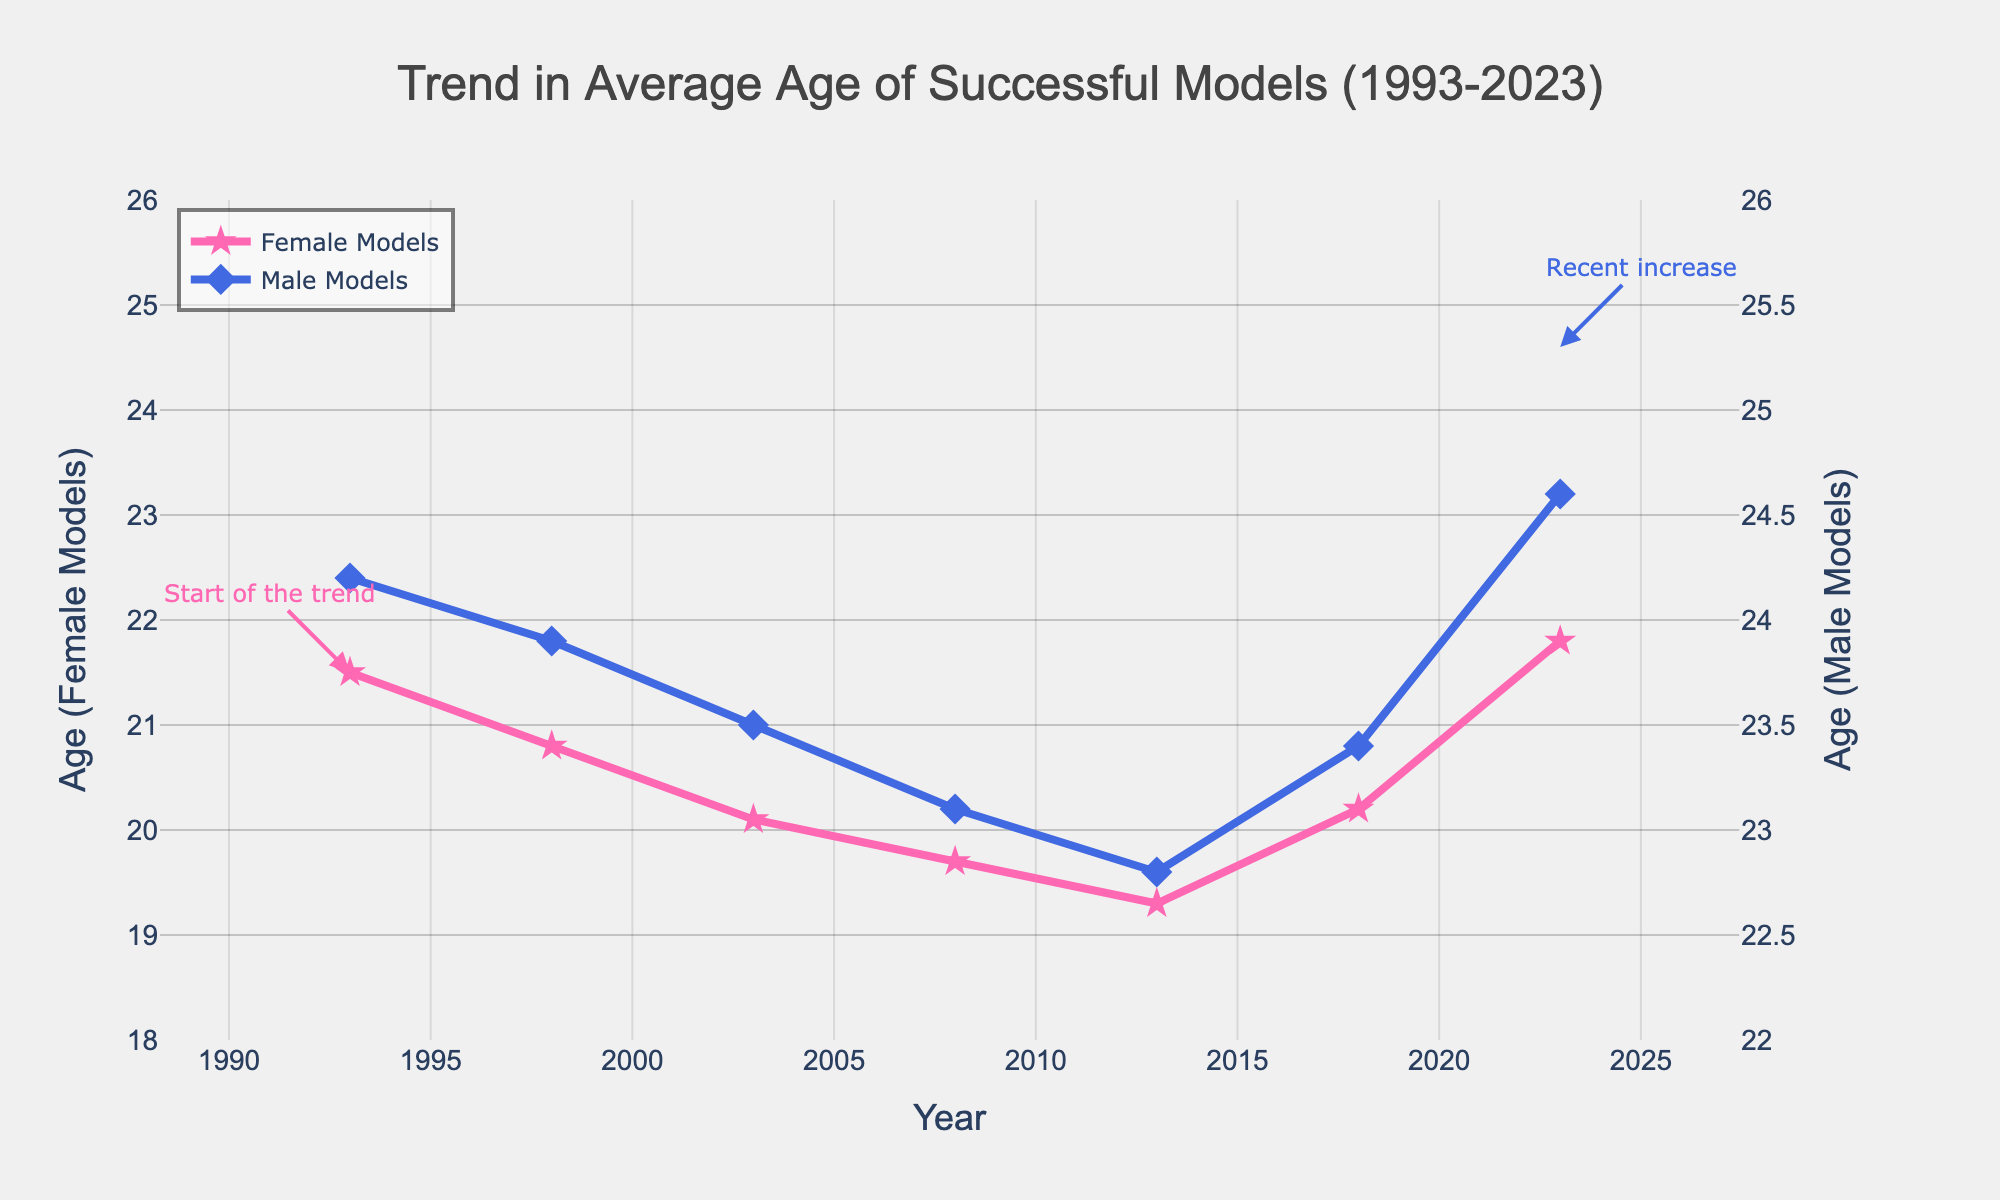What is the overall trend in the average age of female models between 1993 and 2023? The trend for female models' average age shows a decrease from 21.5 years in 1993 to a low of 19.3 years in 2013, followed by an increase to 21.8 years in 2023.
Answer: Decrease, then increase How does the trend in the average age of male models compare to that of female models over the 30-year period? While the average age of female models decreases initially and then increases, the average age of male models consistently decreases until 2013, before seeing a rise again in recent years.
Answer: Consistent decrease, then increase What was the lowest average age for female models and in which year did it occur? The lowest average age for female models was 19.3 years, which occurred in 2013.
Answer: 19.3 years, 2013 Between which years did the average age of female models show the most significant decrease? The most significant decrease in the average age for female models occurred between 1993 and 2008, where it dropped from 21.5 years to 19.7 years.
Answer: Between 1993 and 2008 What is the difference in the average age of male models between 1993 and 2023? The average age of male models in 1993 was 24.2 years, and in 2023 it was 24.6 years, resulting in a difference of 0.4 years.
Answer: 0.4 years In which year did both male and female models experience an increase in their average age compared to the previous measurement? Both male and female models experienced an increase in their average age in 2018 compared to 2013.
Answer: 2018 By how much did the average age of female models increase from its lowest point in 2013 to 2023? The average age of female models in 2013 was 19.3 years and in 2023 it was 21.8 years, resulting in an increase of 2.5 years.
Answer: 2.5 years What was the average age of male models in 2008, and how does it compare to female models in the same year? The average age of male models in 2008 was 23.1 years while for female models it was 19.7 years. So, male models were on average 3.4 years older than female models in 2008.
Answer: 23.1 years, 3.4 years older Which gender experienced a greater overall change in average age from 1993 to 2023? The average age of female models changed from 21.5 years in 1993 to 21.8 years in 2023 (a change of +0.3 years), while male models went from 24.2 years to 24.6 years (a change of +0.4 years). Thus, male models experienced a slightly greater overall change.
Answer: Male models 